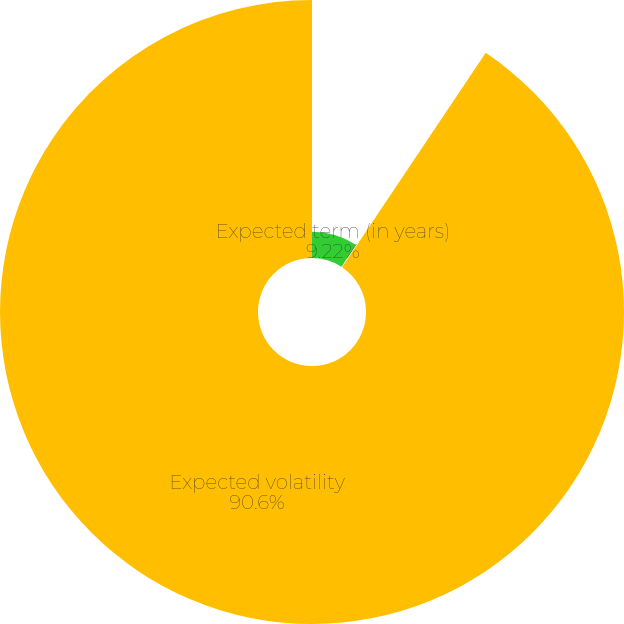Convert chart. <chart><loc_0><loc_0><loc_500><loc_500><pie_chart><fcel>Expected term (in years)<fcel>Risk-free interest rate<fcel>Expected volatility<nl><fcel>9.22%<fcel>0.18%<fcel>90.6%<nl></chart> 